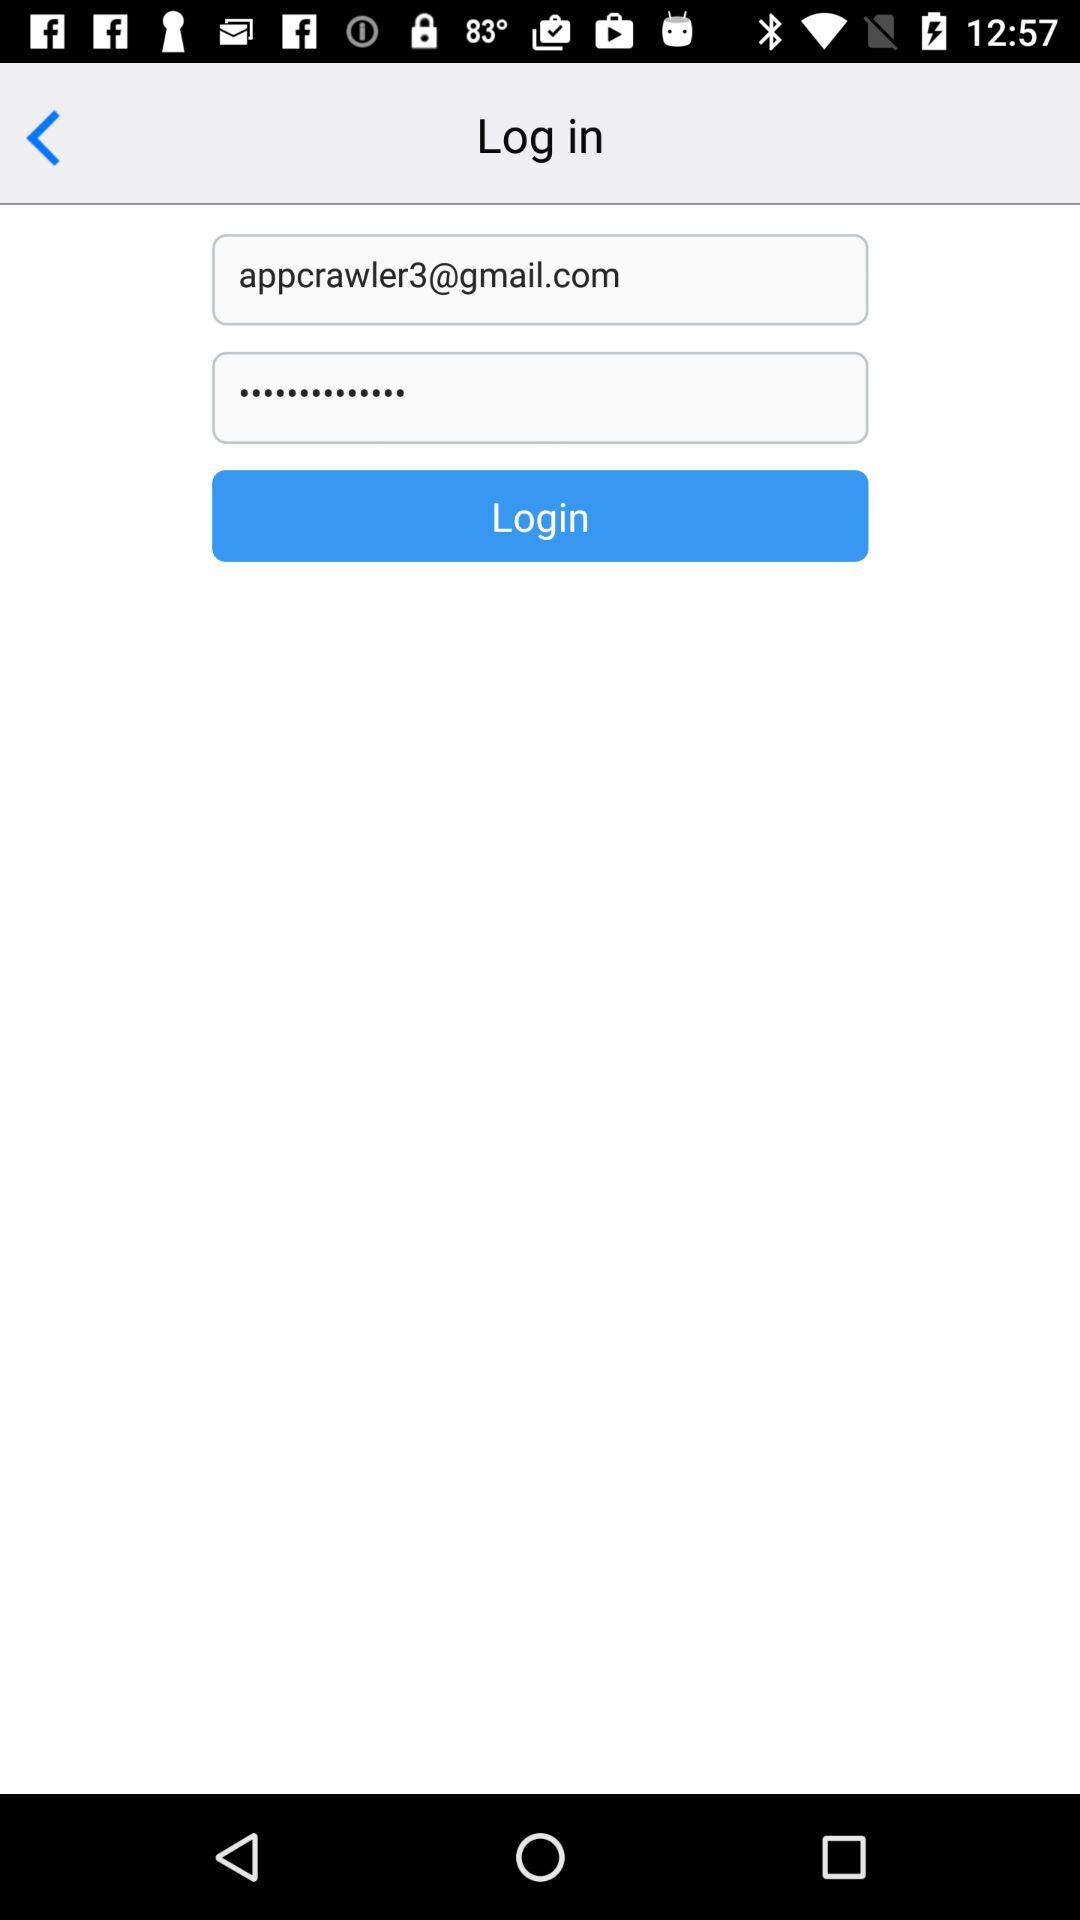What is the login email address? The login email address is appcrawler3@gmail.com. 